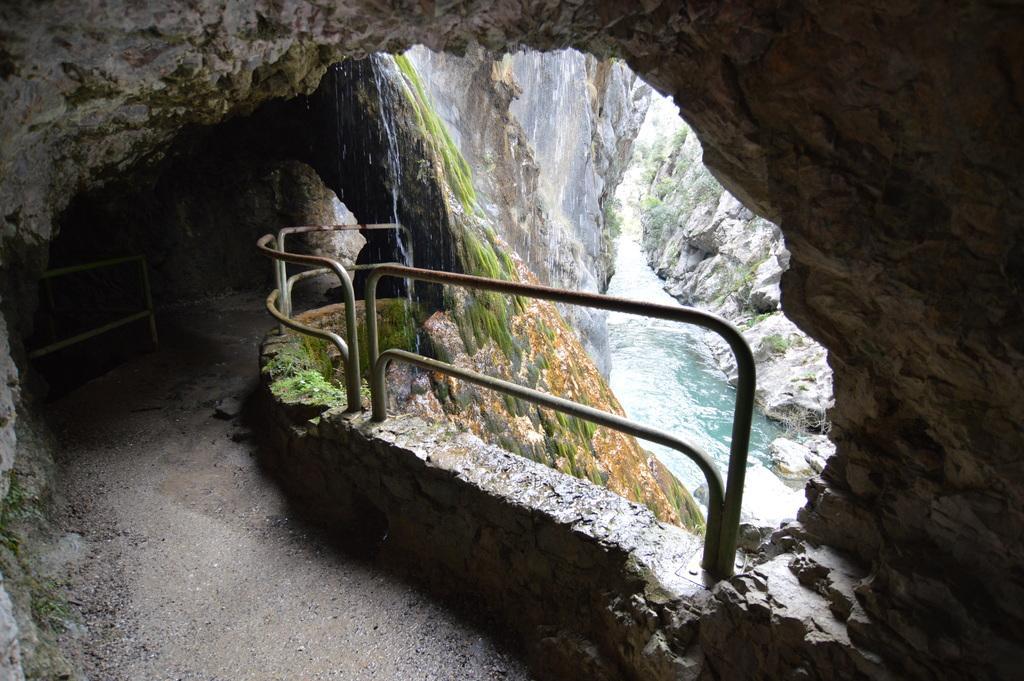Please provide a concise description of this image. In this image there is a way on the left side bottom. It looks like a tunnel. Beside the way there is a fence. In the middle there is a flow of water. This image is taken in between the hills. 